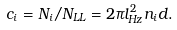Convert formula to latex. <formula><loc_0><loc_0><loc_500><loc_500>c _ { i } = N _ { i } / N _ { L L } = 2 \pi l _ { H z } ^ { 2 } n _ { i } d .</formula> 